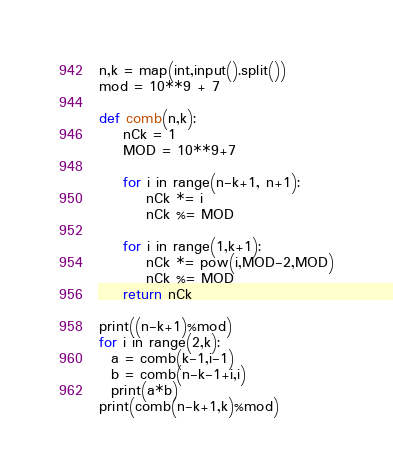Convert code to text. <code><loc_0><loc_0><loc_500><loc_500><_Python_>n,k = map(int,input().split())
mod = 10**9 + 7

def comb(n,k):
    nCk = 1
    MOD = 10**9+7

    for i in range(n-k+1, n+1):
        nCk *= i
        nCk %= MOD

    for i in range(1,k+1):
        nCk *= pow(i,MOD-2,MOD)
        nCk %= MOD
    return nCk
  
print((n-k+1)%mod)  
for i in range(2,k):
  a = comb(k-1,i-1)
  b = comb(n-k-1+i,i)
  print(a*b)
print(comb(n-k+1,k)%mod)</code> 